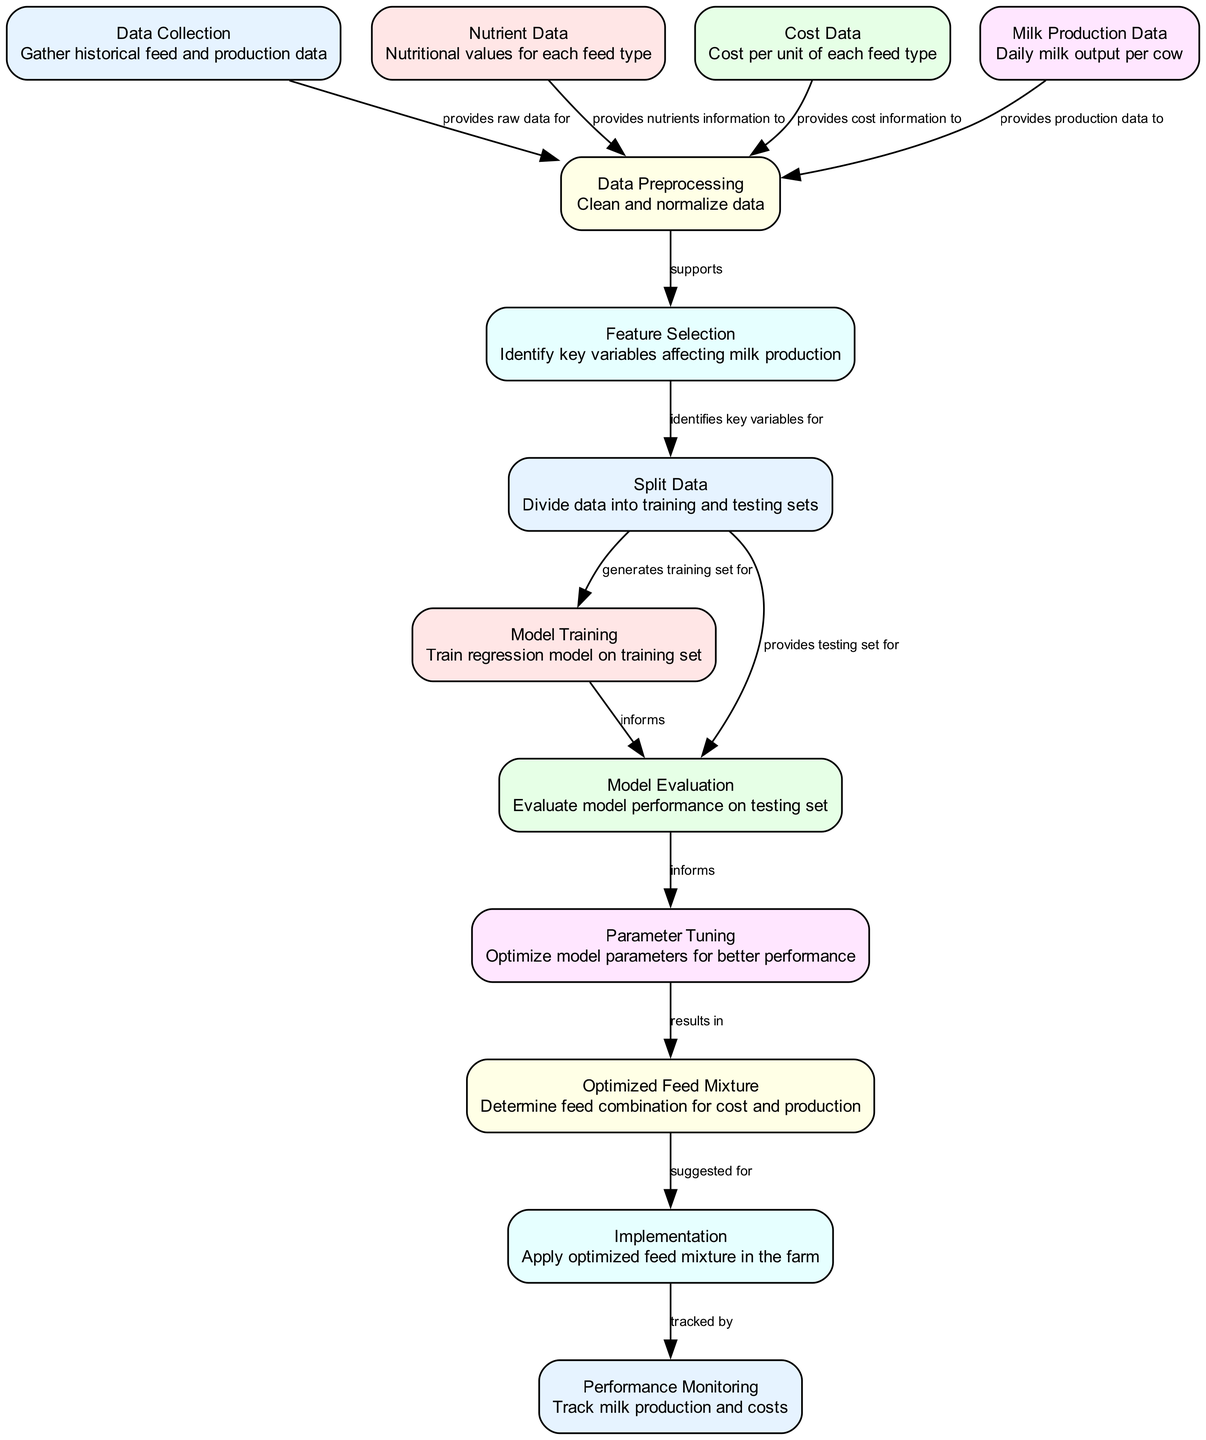How many nodes are present in the diagram? By counting each distinct labeled rectangle representing a component of the process, we can see that there are 12 nodes in total.
Answer: 12 What does the 'Data Collection' node provide for the process? The 'Data Collection' node provides raw data for data preprocessing, as indicated by the labeled edge connecting it to the data preprocessing node.
Answer: raw data Which node follows 'Parameter Tuning' in the flow of the diagram? After 'Parameter Tuning', the flow continues to the 'Optimized Feed Mixture' node, as shown by the directed edge leading from parameter tuning to the optimized feed mixture.
Answer: Optimized Feed Mixture How many edges connect 'Split Data' with model training and evaluation? 'Split Data' connects with two different nodes: 'Model Training' and 'Model Evaluation'. Thus, it has 2 outgoing edges.
Answer: 2 What component is monitored after the implementation of the optimized feed mixture? The component monitored after implementation is 'Performance Monitoring', as shown in the diagram by the directed edge leading from implementation to performance monitoring.
Answer: Performance Monitoring What is the main purpose of the 'Feature Selection' node? The 'Feature Selection' node identifies key variables affecting milk production, which is specifically mentioned in the description provided in the diagram.
Answer: Identify key variables Which node provides cost information for data preprocessing? The 'Cost Data' node provides cost information, as it is connected to the 'Data Preprocessing' node with a labeled edge indicating its role in supplying necessary information.
Answer: Cost Data How does 'Model Evaluation' influence 'Parameter Tuning'? 'Model Evaluation' informs the 'Parameter Tuning' process, indicating that the performance assessment of the model impacts how parameters are adjusted for optimization.
Answer: informs What does the 'Optimized Feed Mixture' suggest for? The 'Optimized Feed Mixture' node suggests the feed combination for minimizing costs and maximizing milk production, as indicated in its description within the diagram.
Answer: suggested for 